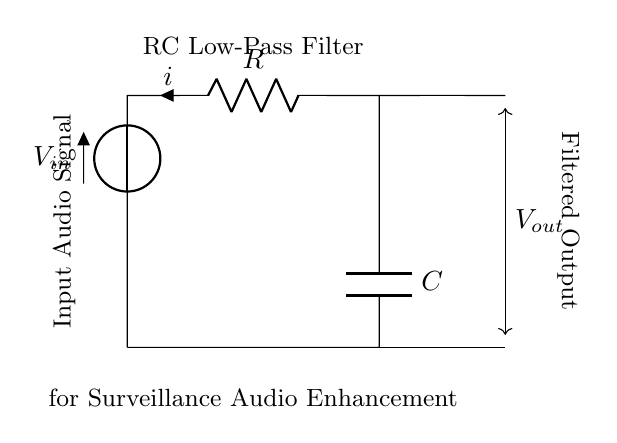What type of filter is represented in this circuit? The circuit diagram shows an RC low-pass filter, which allows low-frequency signals to pass while attenuating high-frequency signals. This is evident from the label "RC Low-Pass Filter" placed above the circuit.
Answer: RC low-pass filter What components are used in this circuit? The components in the circuit are a resistor labeled 'R' and a capacitor labeled 'C'. These components are fundamental to the RC filter configuration, which is clearly indicated in their respective designations in the diagram.
Answer: Resistor and capacitor What does V_in represent in the circuit? V_in represents the input audio signal voltage supplied to the filter. This is illustrated by the voltage source labeled 'V' at the input side of the circuit.
Answer: Input audio signal voltage What is the output voltage denoted as in this circuit? The output voltage is indicated as 'V_out' on the right side of the circuit. This represents the voltage after the filtered audio has passed through the RC components.
Answer: V_out How does the resistor affect the circuit behavior? The resistor 'R' plays a crucial role in determining the cutoff frequency of the low-pass filter. By working in combination with the capacitor, it influences how quickly the circuit responds to changes in the input signal and establishes the time constant of the filter.
Answer: It influences the cutoff frequency What is the purpose of this RC filter in surveillance systems? The purpose of the RC filter in surveillance systems is to enhance audio recording by filtering out unwanted high-frequency noise, ensuring that clearer audio signals are captured for analysis. This functionality is implied by the labeling stating "for Surveillance Audio Enhancement."
Answer: Enhance audio recording What happens to high-frequency signals in this filter configuration? High-frequency signals are attenuated or reduced in amplitude as they pass through the RC low-pass filter, allowing mainly low-frequency signals to pass through unhindered. This aspect is fundamental to the filter's design and purpose as stated in the description.
Answer: Attenuated 